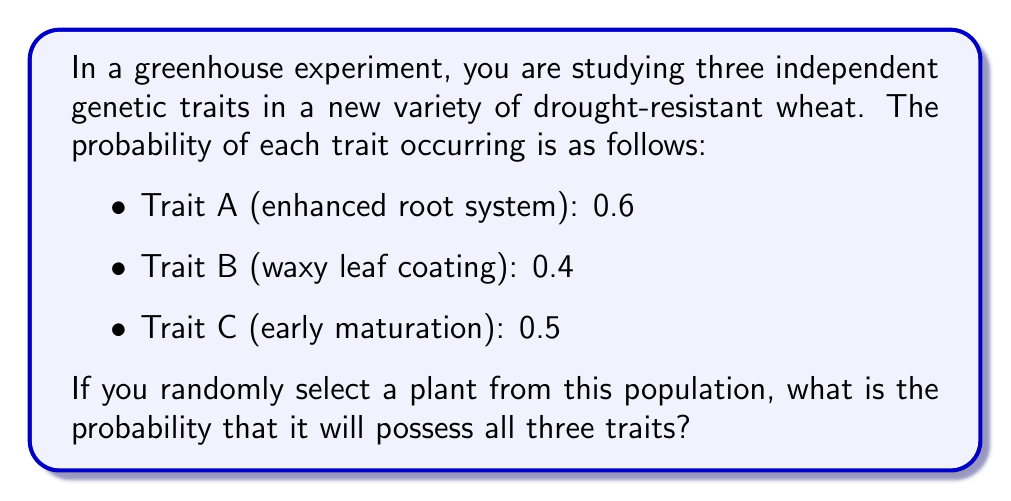What is the answer to this math problem? Let's approach this step-by-step:

1) First, we need to understand that these traits are independent. This means the occurrence of one trait does not affect the probability of another trait occurring.

2) When we want to calculate the probability of multiple independent events all occurring together, we multiply their individual probabilities.

3) Let's define our events:
   - A: The plant has an enhanced root system (Trait A)
   - B: The plant has a waxy leaf coating (Trait B)
   - C: The plant exhibits early maturation (Trait C)

4) We want to find P(A and B and C)

5) Given:
   P(A) = 0.6
   P(B) = 0.4
   P(C) = 0.5

6) Since the events are independent:

   $$P(A \text{ and } B \text{ and } C) = P(A) \times P(B) \times P(C)$$

7) Substituting the values:

   $$P(A \text{ and } B \text{ and } C) = 0.6 \times 0.4 \times 0.5$$

8) Calculating:

   $$P(A \text{ and } B \text{ and } C) = 0.12$$

Therefore, the probability of a randomly selected plant possessing all three traits is 0.12 or 12%.
Answer: 0.12 